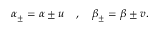Convert formula to latex. <formula><loc_0><loc_0><loc_500><loc_500>\alpha _ { \pm } = \alpha \pm u \quad , \quad \beta _ { \pm } = \beta \pm v .</formula> 